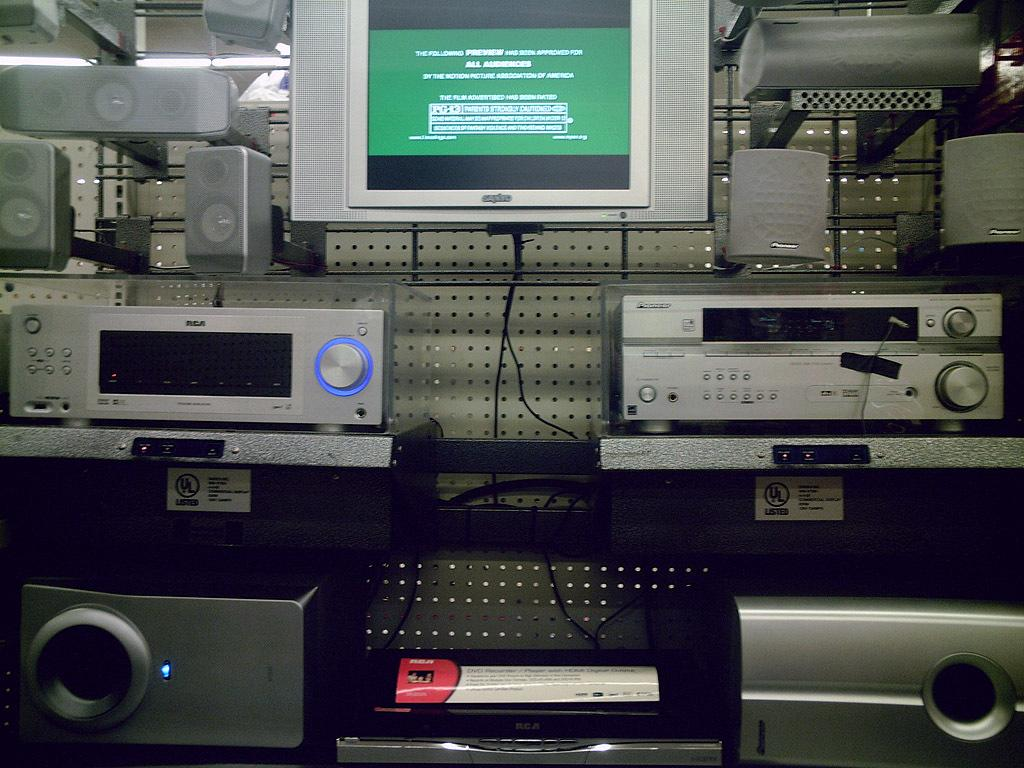<image>
Write a terse but informative summary of the picture. A TV screen displays a preview message stating that it is "approved for all audiences" 